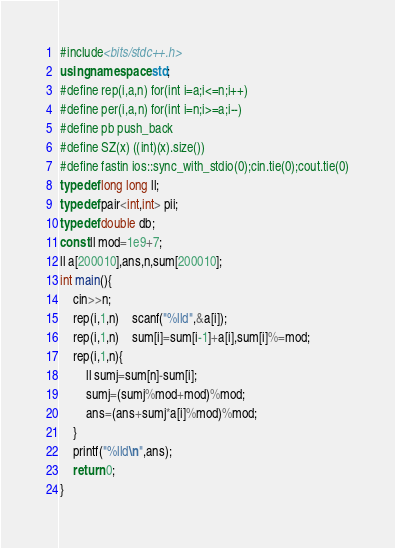Convert code to text. <code><loc_0><loc_0><loc_500><loc_500><_C++_>#include<bits/stdc++.h>
using namespace std;
#define rep(i,a,n) for(int i=a;i<=n;i++)
#define per(i,a,n) for(int i=n;i>=a;i--)
#define pb push_back
#define SZ(x) ((int)(x).size())
#define fastin ios::sync_with_stdio(0);cin.tie(0);cout.tie(0)
typedef long long ll;
typedef pair<int,int> pii;
typedef double db;
const ll mod=1e9+7;
ll a[200010],ans,n,sum[200010];
int main(){
	cin>>n;
	rep(i,1,n)	scanf("%lld",&a[i]);
	rep(i,1,n)	sum[i]=sum[i-1]+a[i],sum[i]%=mod;
	rep(i,1,n){
		ll sumj=sum[n]-sum[i];
		sumj=(sumj%mod+mod)%mod;
		ans=(ans+sumj*a[i]%mod)%mod;
	}
	printf("%lld\n",ans);
	return 0;
}
</code> 